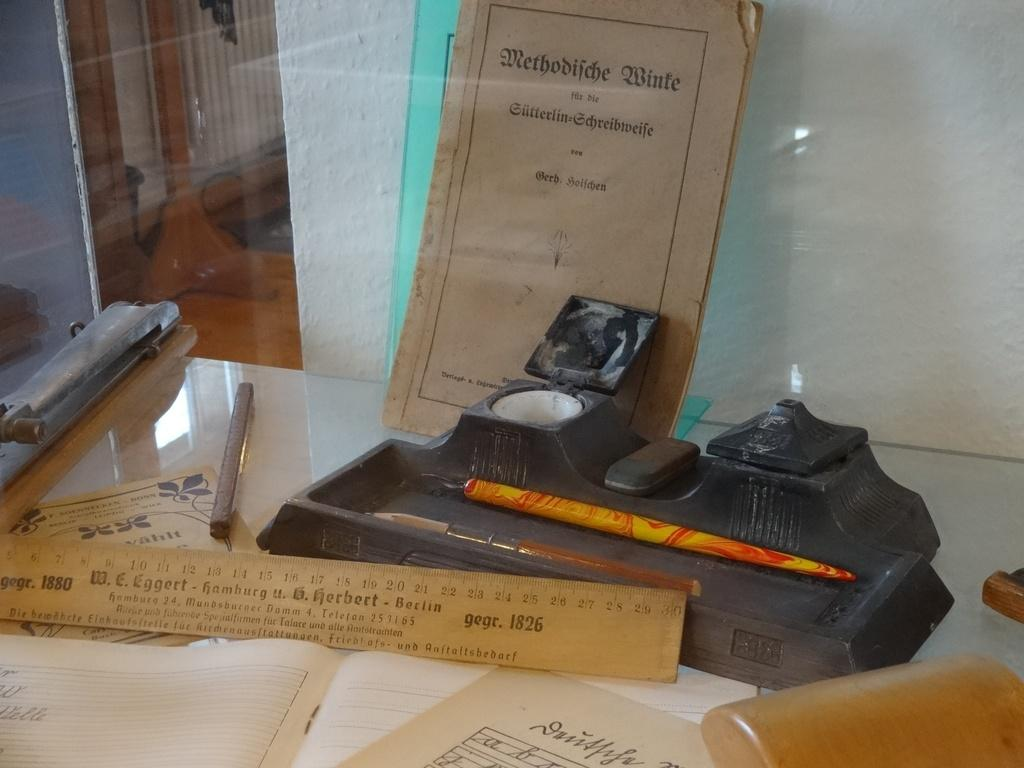What type of furniture is present in the image? There is a table in the image. What items can be seen on the table? There are books, a ruler, a file, a stick, and a black object on the table. What is the purpose of the ruler on the table? The ruler on the table is likely used for measuring or drawing straight lines. What is the color of the wall in the image? The color of the wall in the image is not mentioned in the facts provided. How many flies are sitting on the black object in the image? There is no mention of flies in the image, so we cannot determine how many are sitting on the black object. 